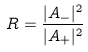<formula> <loc_0><loc_0><loc_500><loc_500>R = \frac { | A _ { - } | ^ { 2 } } { | A _ { + } | ^ { 2 } }</formula> 